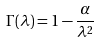Convert formula to latex. <formula><loc_0><loc_0><loc_500><loc_500>\Gamma ( \lambda ) = 1 - \frac { \alpha } { \lambda ^ { 2 } }</formula> 